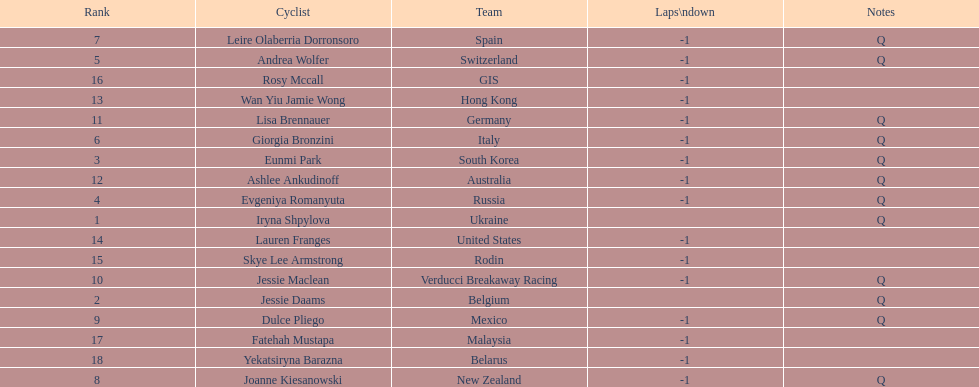What is the number rank of belgium? 2. 